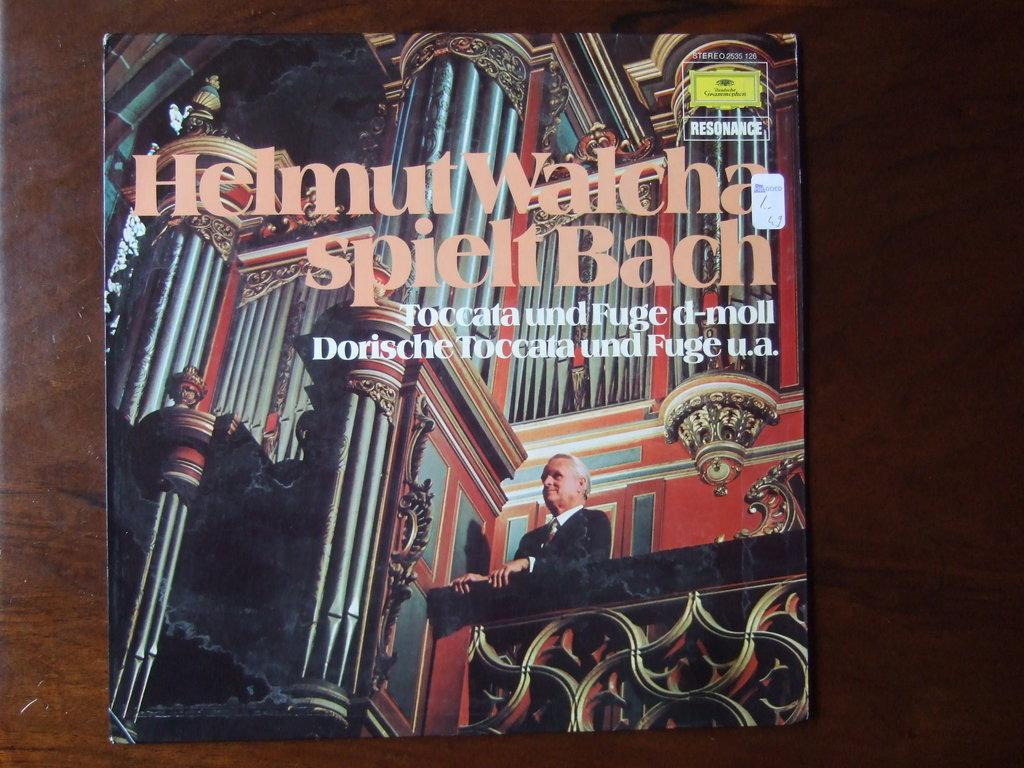<image>
Relay a brief, clear account of the picture shown. An image of a man on a balcony with Helmut Walcha as the first title line. 